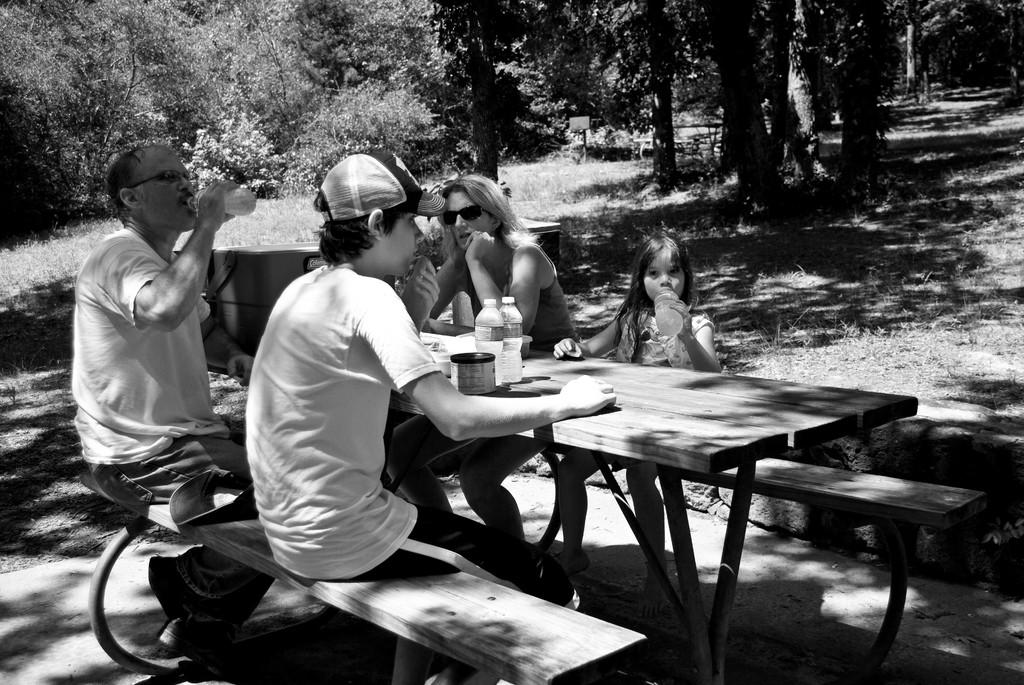What are the people in the image doing? The people in the image are sitting. What can be seen on the table in the image? There are objects on the table in the image. What type of vegetation is visible in the background of the image? There are trees in the background of the image. What type of ground surface is visible in the image? There is grass visible in the image. What type of quartz can be seen in the image? There is no quartz present in the image. Is there a porter carrying luggage in the image? There is no porter or luggage present in the image. 